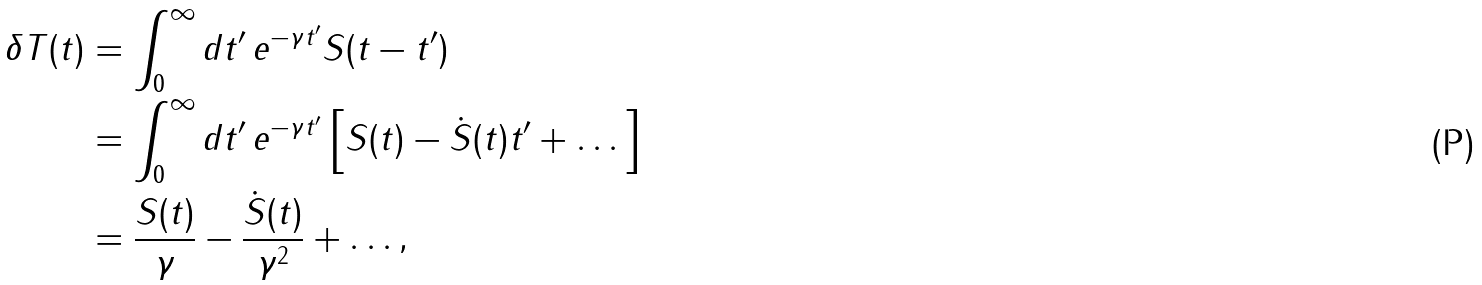<formula> <loc_0><loc_0><loc_500><loc_500>\delta T ( t ) & = \int _ { 0 } ^ { \infty } d t ^ { \prime } \, e ^ { - \gamma t ^ { \prime } } S ( t - t ^ { \prime } ) \\ & = \int _ { 0 } ^ { \infty } d t ^ { \prime } \, e ^ { - \gamma t ^ { \prime } } \left [ S ( t ) - \dot { S } ( t ) t ^ { \prime } + \dots \right ] \\ & = \frac { S ( t ) } { \gamma } - \frac { \dot { S } ( t ) } { \gamma ^ { 2 } } + \dots ,</formula> 